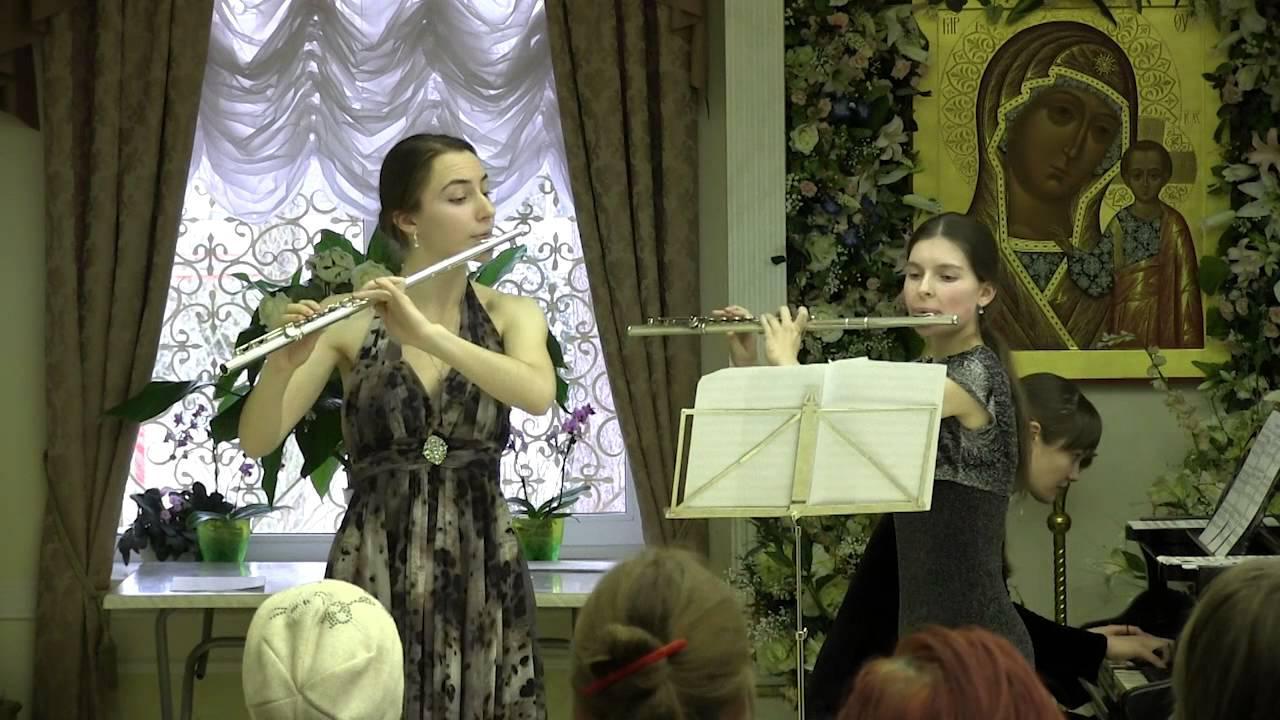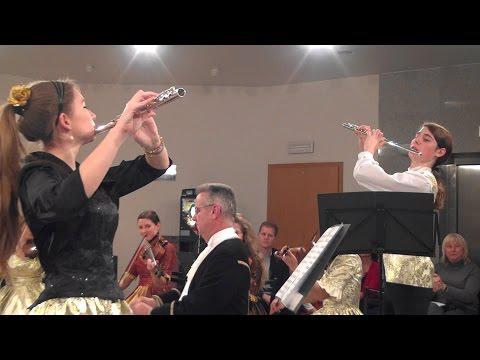The first image is the image on the left, the second image is the image on the right. Given the left and right images, does the statement "One person is playing two instruments at once in the image on the left." hold true? Answer yes or no. No. 